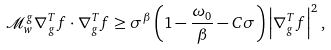Convert formula to latex. <formula><loc_0><loc_0><loc_500><loc_500>\mathcal { M } _ { w } ^ { g } \nabla _ { g } ^ { T } f \cdot \nabla _ { g } ^ { T } f \geq { \sigma } ^ { \beta } \left ( 1 - \frac { \omega _ { 0 } } { \beta } - C \sigma \right ) \left | \nabla _ { g } ^ { T } f \right | ^ { 2 } ,</formula> 